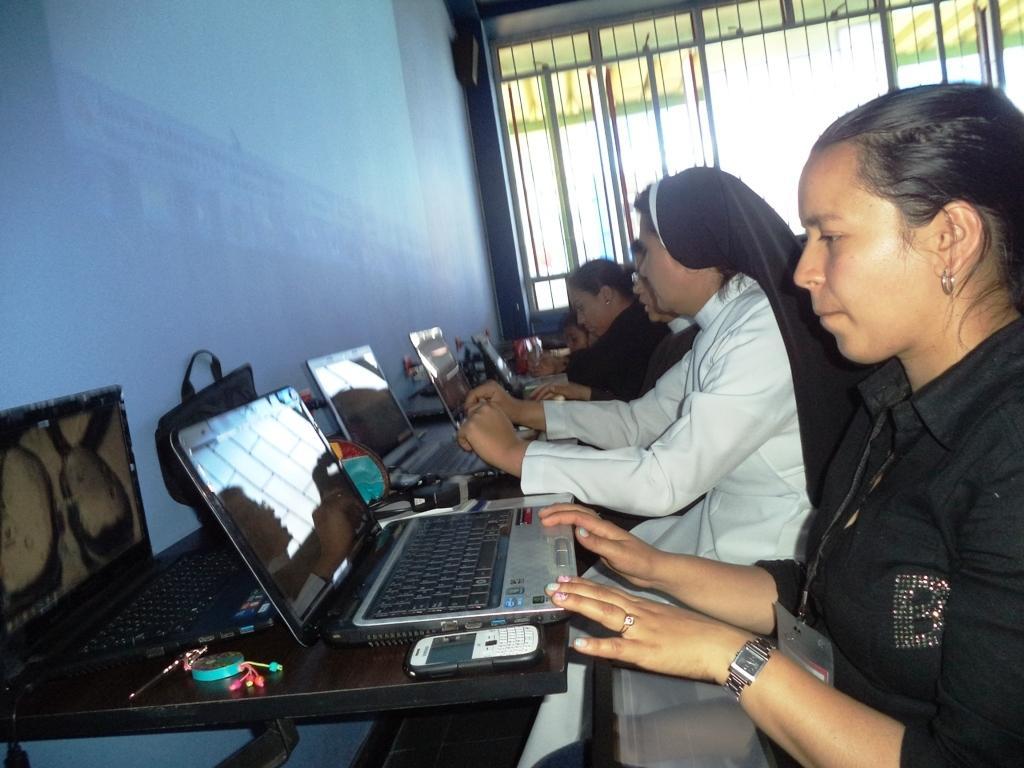In one or two sentences, can you explain what this image depicts? In this image there are women sitting. In front of them there is a table. On the table there are laptops, bags, keys and a mobile phone. Behind the table there is the wall. To the right there are windows to the wall. 